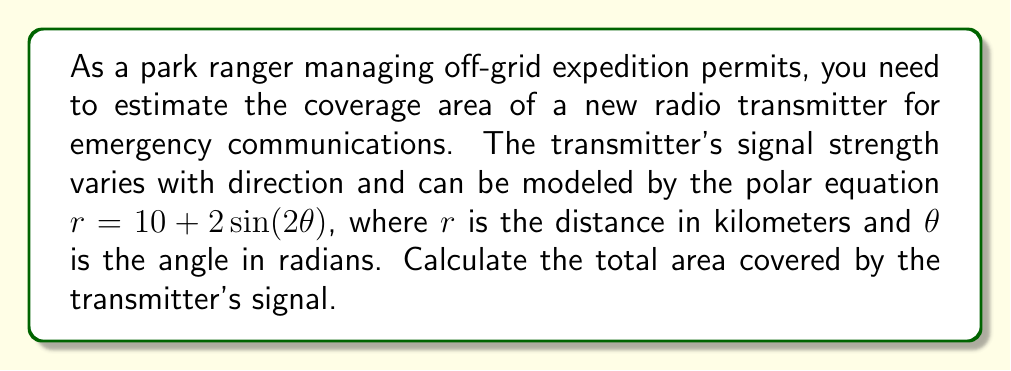Help me with this question. To find the area covered by the transmitter's signal, we need to calculate the area enclosed by the polar curve $r = 10 + 2\sin(2\theta)$ over a complete revolution (0 to $2\pi$).

The formula for the area of a region bounded by a polar curve is:

$$A = \frac{1}{2} \int_{0}^{2\pi} r^2 d\theta$$

Let's follow these steps:

1) Substitute the given equation into the area formula:
   $$A = \frac{1}{2} \int_{0}^{2\pi} (10 + 2\sin(2\theta))^2 d\theta$$

2) Expand the integrand:
   $$A = \frac{1}{2} \int_{0}^{2\pi} (100 + 40\sin(2\theta) + 4\sin^2(2\theta)) d\theta$$

3) Use the identity $\sin^2(2\theta) = \frac{1}{2}(1 - \cos(4\theta))$:
   $$A = \frac{1}{2} \int_{0}^{2\pi} (100 + 40\sin(2\theta) + 2 - 2\cos(4\theta)) d\theta$$
   $$A = \frac{1}{2} \int_{0}^{2\pi} (102 + 40\sin(2\theta) - 2\cos(4\theta)) d\theta$$

4) Integrate term by term:
   $$A = \frac{1}{2} [102\theta - 20\cos(2\theta) - \frac{1}{2}\sin(4\theta)]_{0}^{2\pi}$$

5) Evaluate the definite integral:
   $$A = \frac{1}{2} [(102 \cdot 2\pi - 20\cos(4\pi) - \frac{1}{2}\sin(8\pi)) - (0 - 20\cos(0) - \frac{1}{2}\sin(0))]$$
   $$A = \frac{1}{2} [204\pi - 20 - 0 - (0 - 20 - 0)]$$
   $$A = \frac{1}{2} [204\pi]$$
   $$A = 102\pi$$

Therefore, the total area covered by the transmitter's signal is $102\pi$ square kilometers.
Answer: $102\pi$ square kilometers 